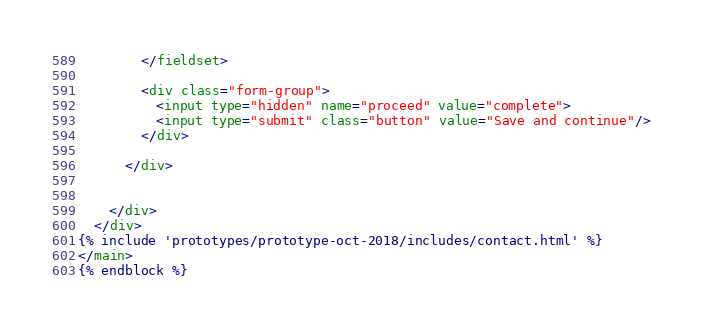Convert code to text. <code><loc_0><loc_0><loc_500><loc_500><_HTML_>        </fieldset>

        <div class="form-group">
          <input type="hidden" name="proceed" value="complete">
          <input type="submit" class="button" value="Save and continue"/>
        </div>

      </div>


    </div>
  </div>
{% include 'prototypes/prototype-oct-2018/includes/contact.html' %}
</main>
{% endblock %}
</code> 